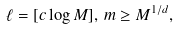<formula> <loc_0><loc_0><loc_500><loc_500>\ell = [ c \log M ] , \, m \geq M ^ { 1 / d } ,</formula> 